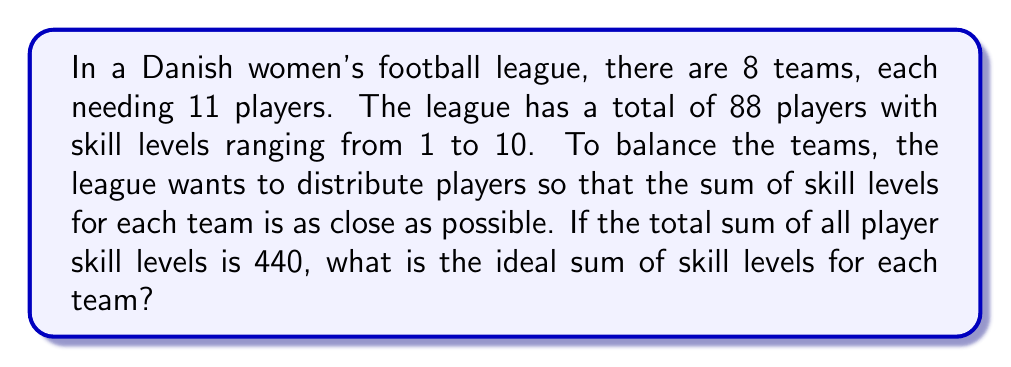Help me with this question. Let's approach this step-by-step:

1) First, we need to calculate the total sum of skill levels:
   Given: Total sum = 440

2) Next, we need to divide this total evenly among the 8 teams:
   
   $$\text{Ideal sum per team} = \frac{\text{Total sum}}{\text{Number of teams}}$$

3) Plugging in our values:

   $$\text{Ideal sum per team} = \frac{440}{8} = 55$$

4) To verify, we can check if this distribution accounts for all skill points:
   
   $$55 \times 8 = 440$$

   This confirms our calculation is correct.

5) In graph theory terms, this problem can be viewed as a graph partitioning problem. Each player would be a vertex, with edges weighted by the difference in skill levels. The goal would be to partition the graph into 8 subgraphs (teams) such that the sum of vertex weights (skill levels) in each subgraph is as close to 55 as possible.

This approach ensures that each team has a balanced total skill level, promoting fair competition in the league.
Answer: The ideal sum of skill levels for each team is 55. 